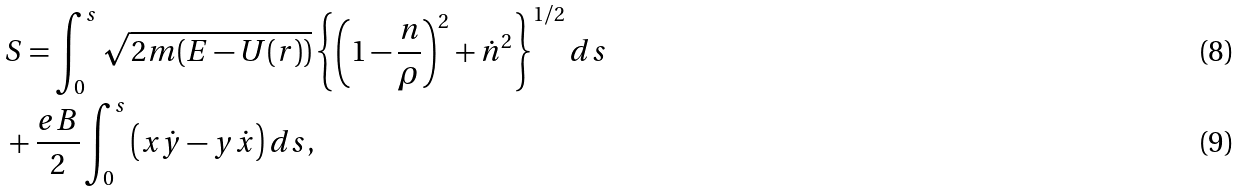Convert formula to latex. <formula><loc_0><loc_0><loc_500><loc_500>& S = \int _ { 0 } ^ { s } \sqrt { 2 m ( E - U ( r ) ) } \left \{ \left ( 1 - \frac { n } { \rho } \right ) ^ { 2 } + { \dot { n } } ^ { 2 } \right \} ^ { 1 / 2 } d s \\ & + \frac { e B } { 2 } \int _ { 0 } ^ { s } \left ( x \dot { y } - y \dot { x } \right ) d s ,</formula> 